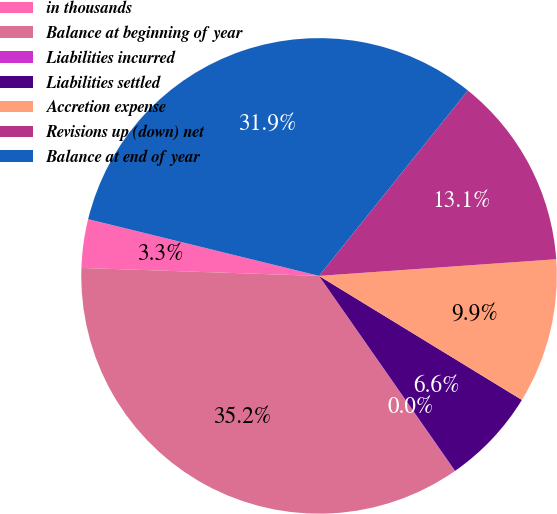Convert chart to OTSL. <chart><loc_0><loc_0><loc_500><loc_500><pie_chart><fcel>in thousands<fcel>Balance at beginning of year<fcel>Liabilities incurred<fcel>Liabilities settled<fcel>Accretion expense<fcel>Revisions up (down) net<fcel>Balance at end of year<nl><fcel>3.3%<fcel>35.2%<fcel>0.03%<fcel>6.57%<fcel>9.85%<fcel>13.12%<fcel>31.93%<nl></chart> 